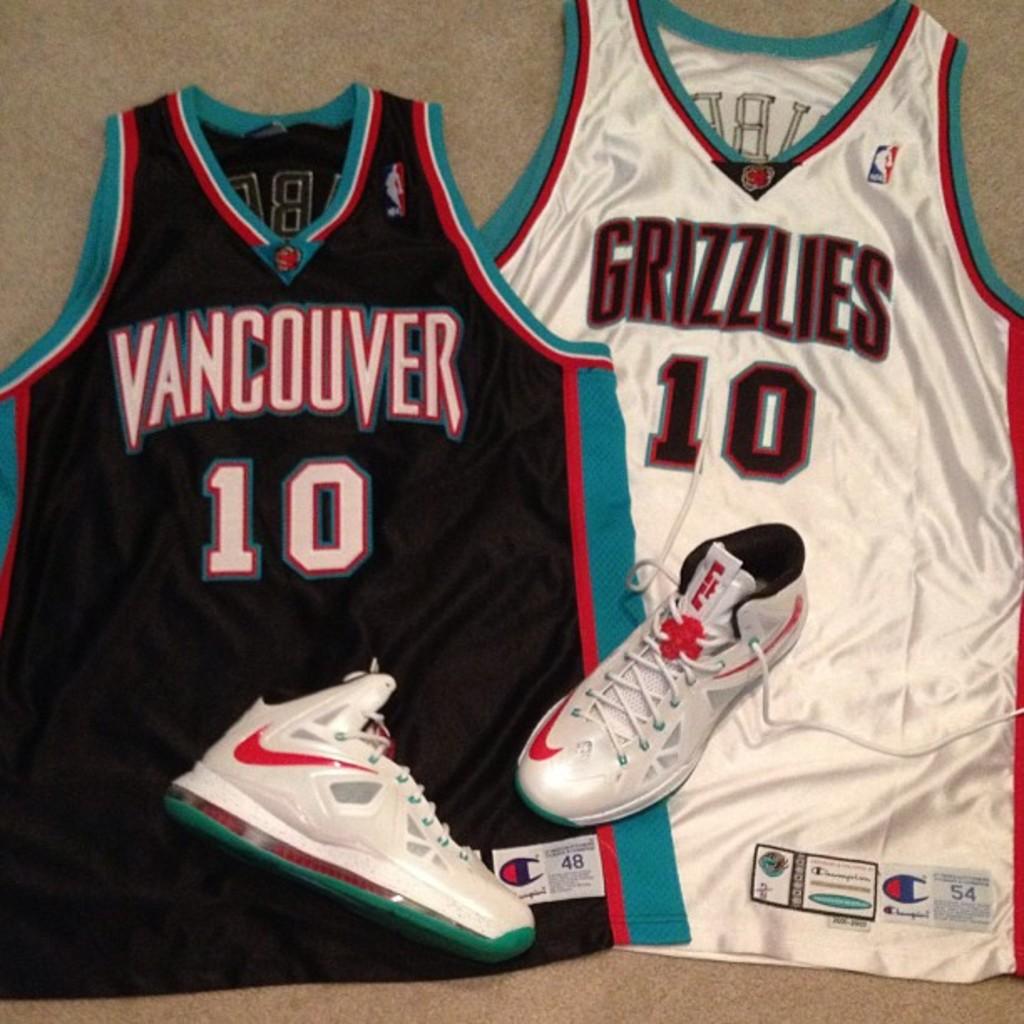What basketball team does the jersey on the left belong to?
Ensure brevity in your answer.  Vancouver. What is the number on the jerseys?
Your answer should be very brief. 10. 